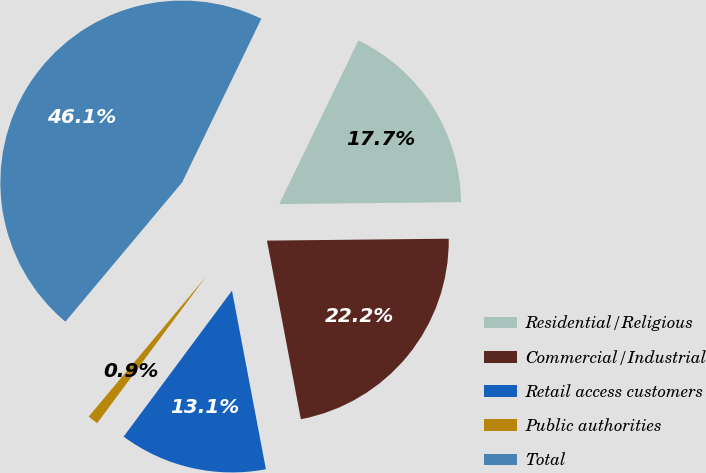Convert chart to OTSL. <chart><loc_0><loc_0><loc_500><loc_500><pie_chart><fcel>Residential/Religious<fcel>Commercial/Industrial<fcel>Retail access customers<fcel>Public authorities<fcel>Total<nl><fcel>17.66%<fcel>22.18%<fcel>13.15%<fcel>0.94%<fcel>46.07%<nl></chart> 